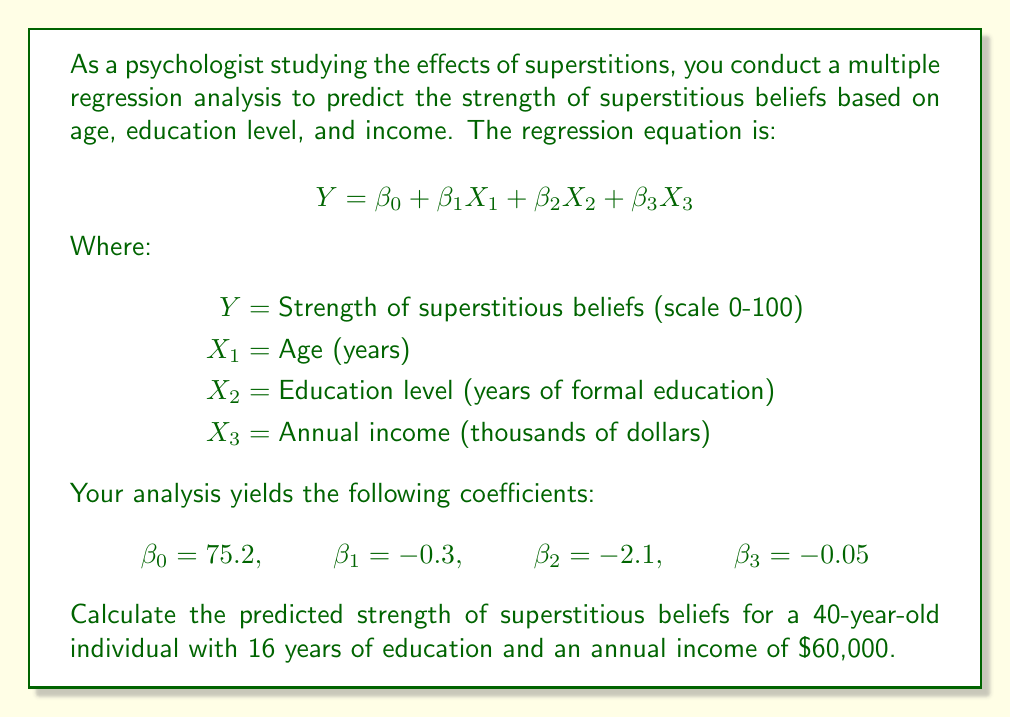Give your solution to this math problem. To solve this problem, we'll follow these steps:

1. Identify the given information:
   $\beta_0 = 75.2$ (intercept)
   $\beta_1 = -0.3$ (coefficient for age)
   $\beta_2 = -2.1$ (coefficient for education level)
   $\beta_3 = -0.05$ (coefficient for income)
   
   $X_1 = 40$ (age)
   $X_2 = 16$ (years of education)
   $X_3 = 60$ (income in thousands)

2. Substitute these values into the regression equation:

   $$Y = \beta_0 + \beta_1X_1 + \beta_2X_2 + \beta_3X_3$$

3. Calculate each term:
   $\beta_0 = 75.2$
   $\beta_1X_1 = -0.3 \times 40 = -12$
   $\beta_2X_2 = -2.1 \times 16 = -33.6$
   $\beta_3X_3 = -0.05 \times 60 = -3$

4. Sum up all the terms:

   $$Y = 75.2 + (-12) + (-33.6) + (-3)$$
   $$Y = 75.2 - 12 - 33.6 - 3$$
   $$Y = 26.6$$

Therefore, the predicted strength of superstitious beliefs for this individual is 26.6 on a scale of 0-100.
Answer: 26.6 